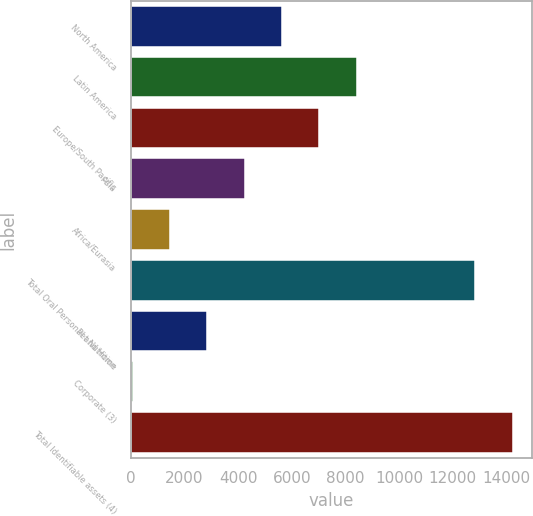Convert chart to OTSL. <chart><loc_0><loc_0><loc_500><loc_500><bar_chart><fcel>North America<fcel>Latin America<fcel>Europe/South Pacific<fcel>Asia<fcel>Africa/Eurasia<fcel>Total Oral Personal and Home<fcel>Pet Nutrition<fcel>Corporate (3)<fcel>Total Identifiable assets (4)<nl><fcel>5633.6<fcel>8417.4<fcel>7025.5<fcel>4241.7<fcel>1457.9<fcel>12832<fcel>2849.8<fcel>66<fcel>14223.9<nl></chart> 